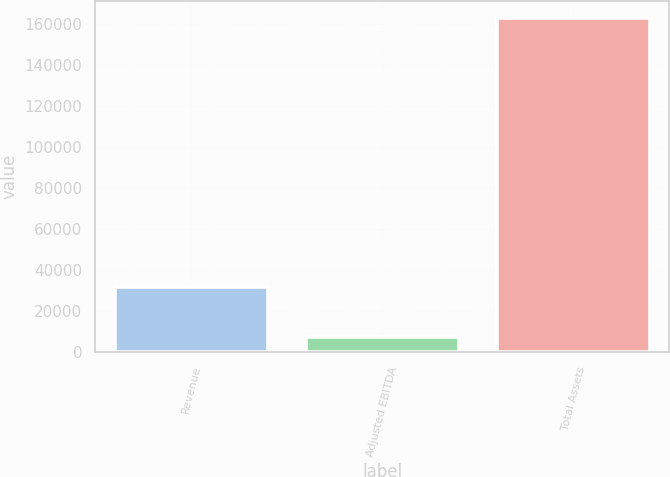Convert chart to OTSL. <chart><loc_0><loc_0><loc_500><loc_500><bar_chart><fcel>Revenue<fcel>Adjusted EBITDA<fcel>Total Assets<nl><fcel>31618<fcel>7348<fcel>163174<nl></chart> 